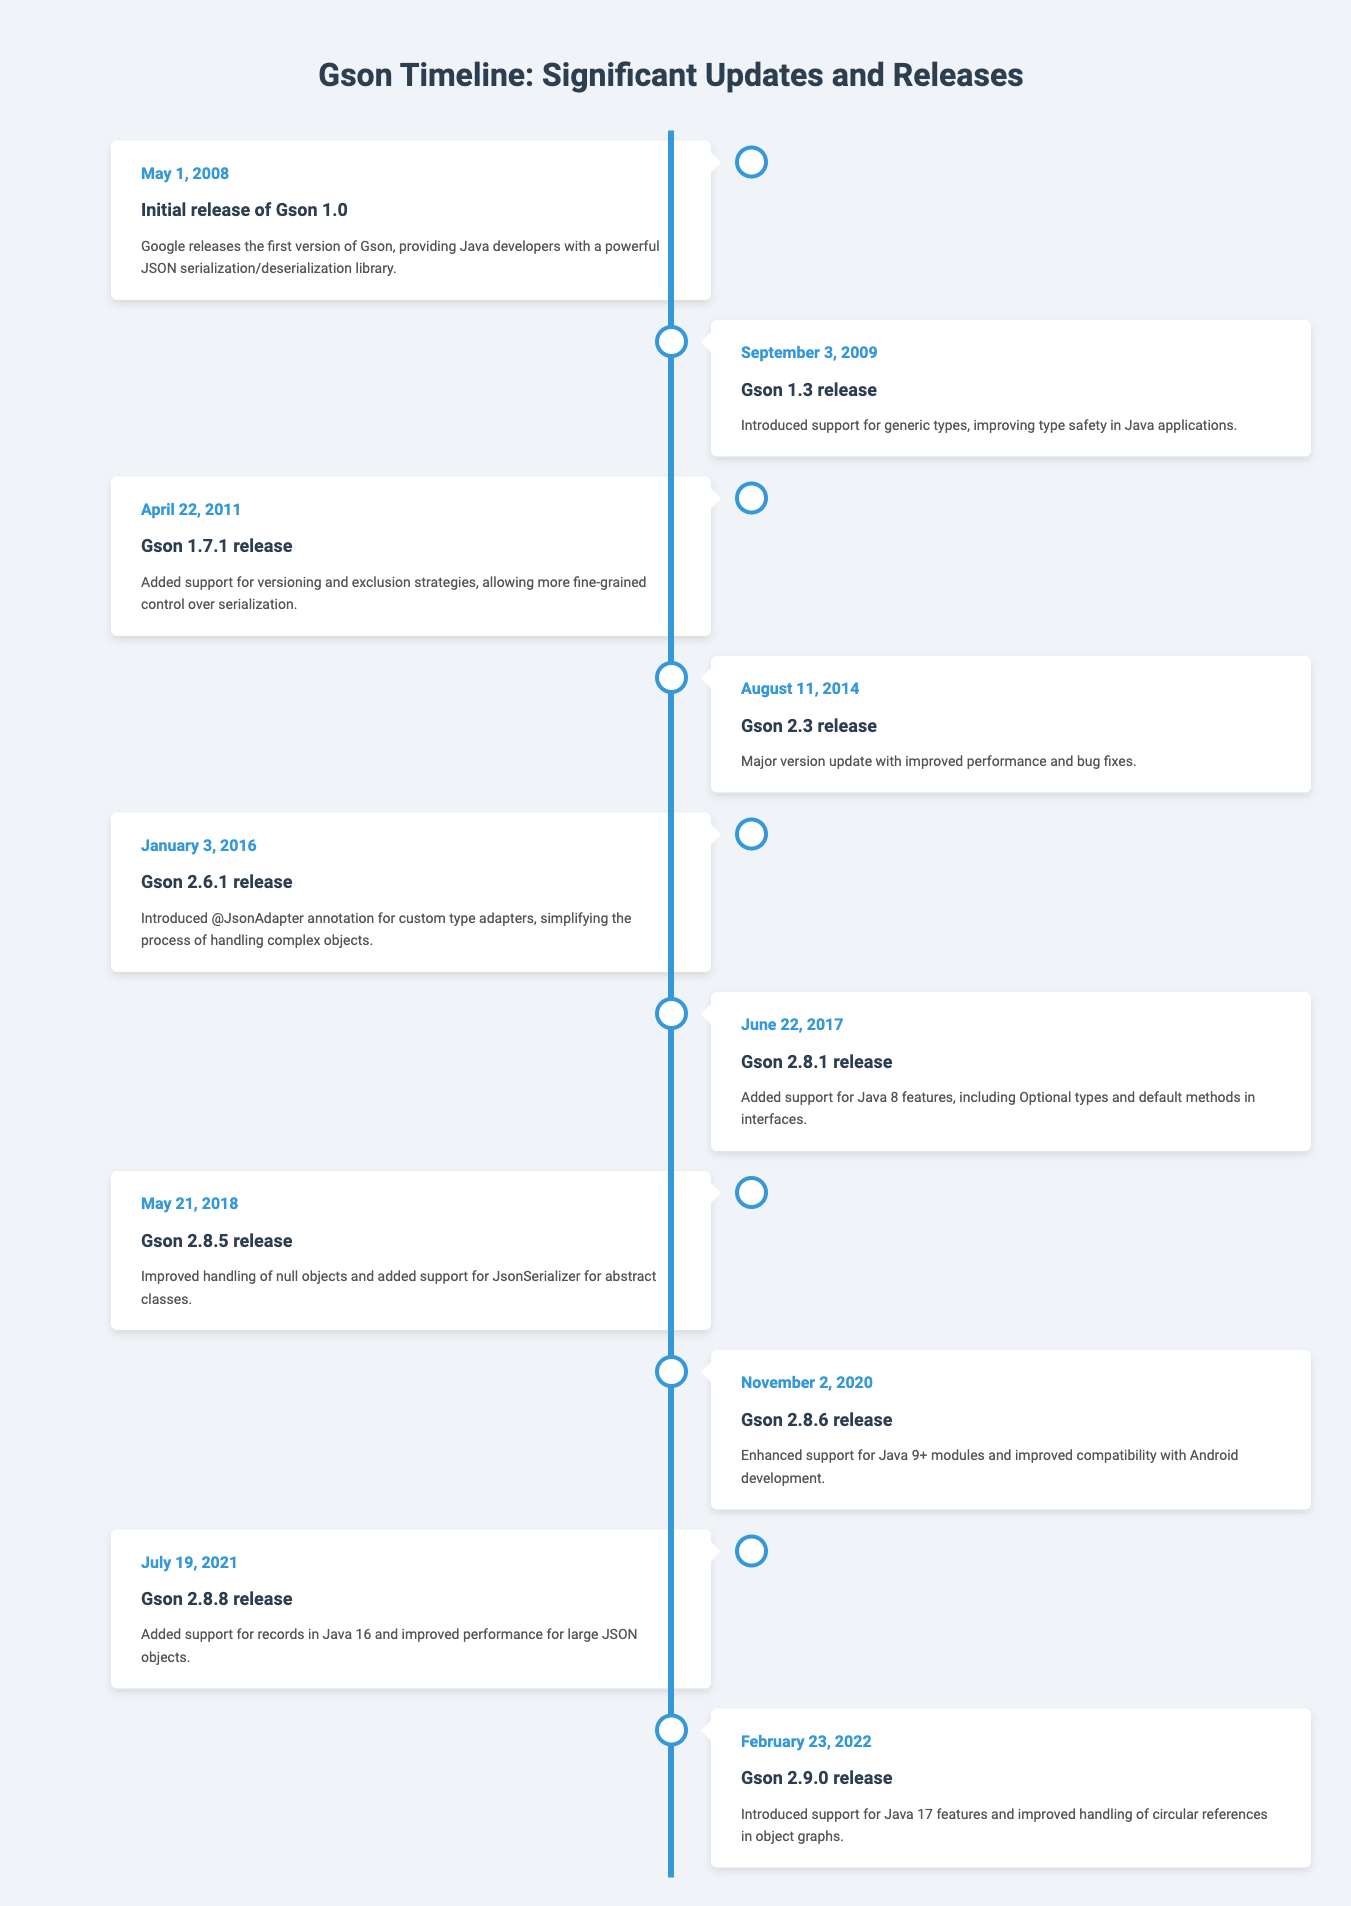What is the date of the initial release of Gson? The table shows that the initial release of Gson occurred on May 1, 2008.
Answer: May 1, 2008 Which version introduced support for generic types? From the timeline, Gson version 1.3 released on September 3, 2009, specifically mentioned the introduction of support for generic types.
Answer: Gson 1.3 What major feature was introduced in Gson 2.6.1? The event for Gson 2.6.1 release on January 3, 2016, highlights that the major feature introduced was the @JsonAdapter annotation for custom type adapters.
Answer: @JsonAdapter annotation How many versions were released between 2009 and 2022? Counting the releases listed from 2009 (Gson 1.3) to 2022 (Gson 2.9.0), there are 7 versions: 1.3, 1.7.1, 2.3, 2.6.1, 2.8.1, 2.8.5, 2.8.6, 2.8.8, and 2.9.0. Thus, the total is 8 versions.
Answer: 8 versions Did Gson 2.8.8 maintain backward compatibility with earlier versions? The timeline does not explicitly state compatibility details, but since it included support for records from Java 16, it likely maintained compatibility by updating features while keeping older functionality. Thus, the answer is yes.
Answer: Yes What was the difference in release years between Gson 2.3 and 2.9.0? Analyzing the years of release, Gson 2.3 was released in 2014 and 2.9.0 was released in 2022. The difference is 2022 - 2014 = 8 years.
Answer: 8 years Which version was the first to support Java 17 features? The entry for the Gson 2.9.0 release on February 23, 2022, indicates that it was the first version to support Java 17 features.
Answer: Gson 2.9.0 What improvements were made in Gson 2.8.6 related to Java modules? The timeline mentions that Gson 2.8.6 release on November 2, 2020, enhanced support for Java 9+ modules.
Answer: Enhanced support for Java 9+ modules How many releases were there related to features introduced after 2016? The releases after 2016 are for versions 2.8.1, 2.8.5, 2.8.6, 2.8.8, and 2.9.0. This counts up to 5 releases featuring enhancements or new features.
Answer: 5 releases 